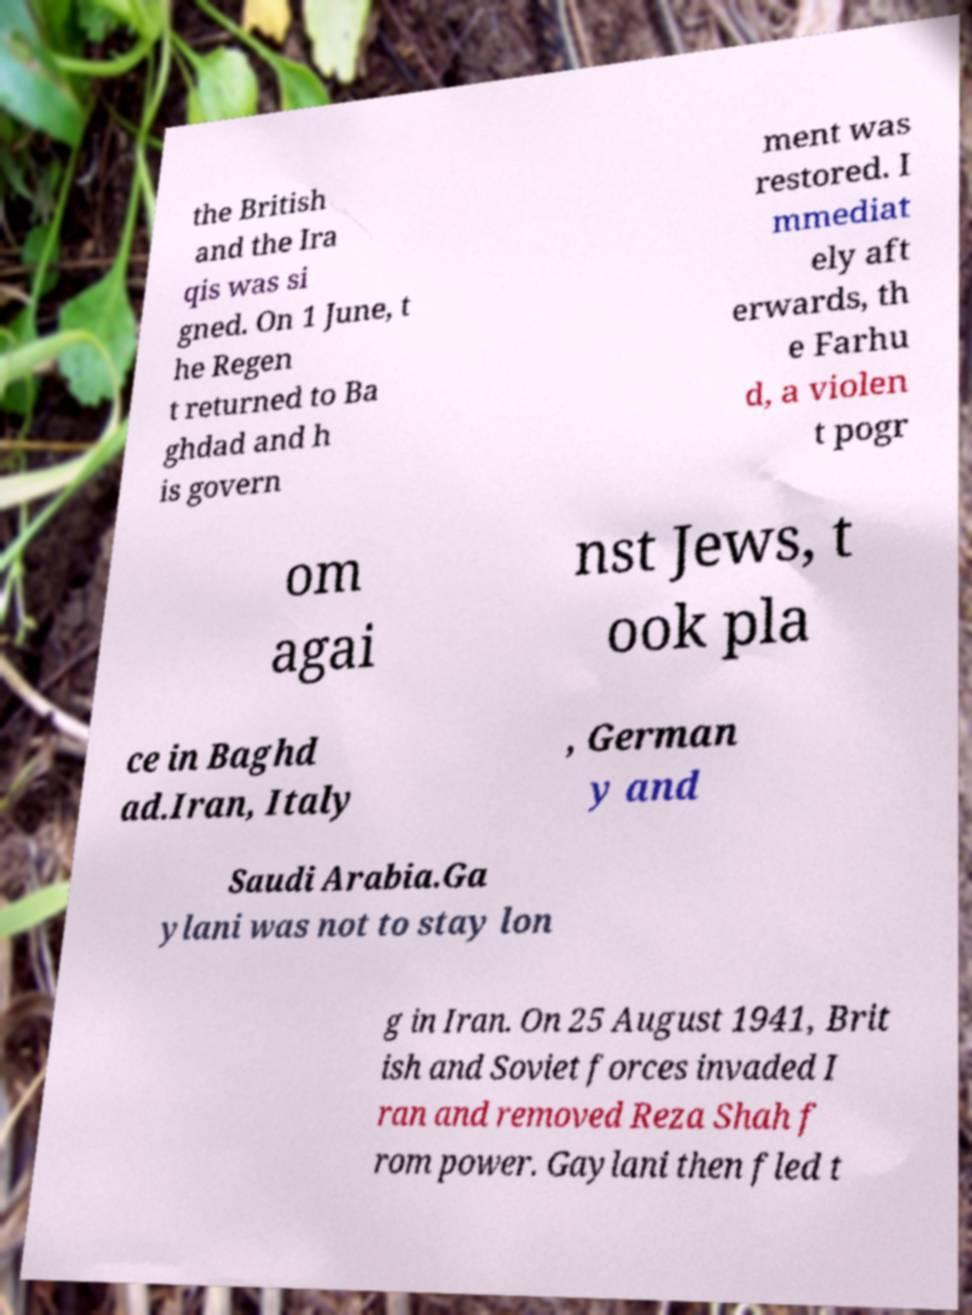For documentation purposes, I need the text within this image transcribed. Could you provide that? the British and the Ira qis was si gned. On 1 June, t he Regen t returned to Ba ghdad and h is govern ment was restored. I mmediat ely aft erwards, th e Farhu d, a violen t pogr om agai nst Jews, t ook pla ce in Baghd ad.Iran, Italy , German y and Saudi Arabia.Ga ylani was not to stay lon g in Iran. On 25 August 1941, Brit ish and Soviet forces invaded I ran and removed Reza Shah f rom power. Gaylani then fled t 